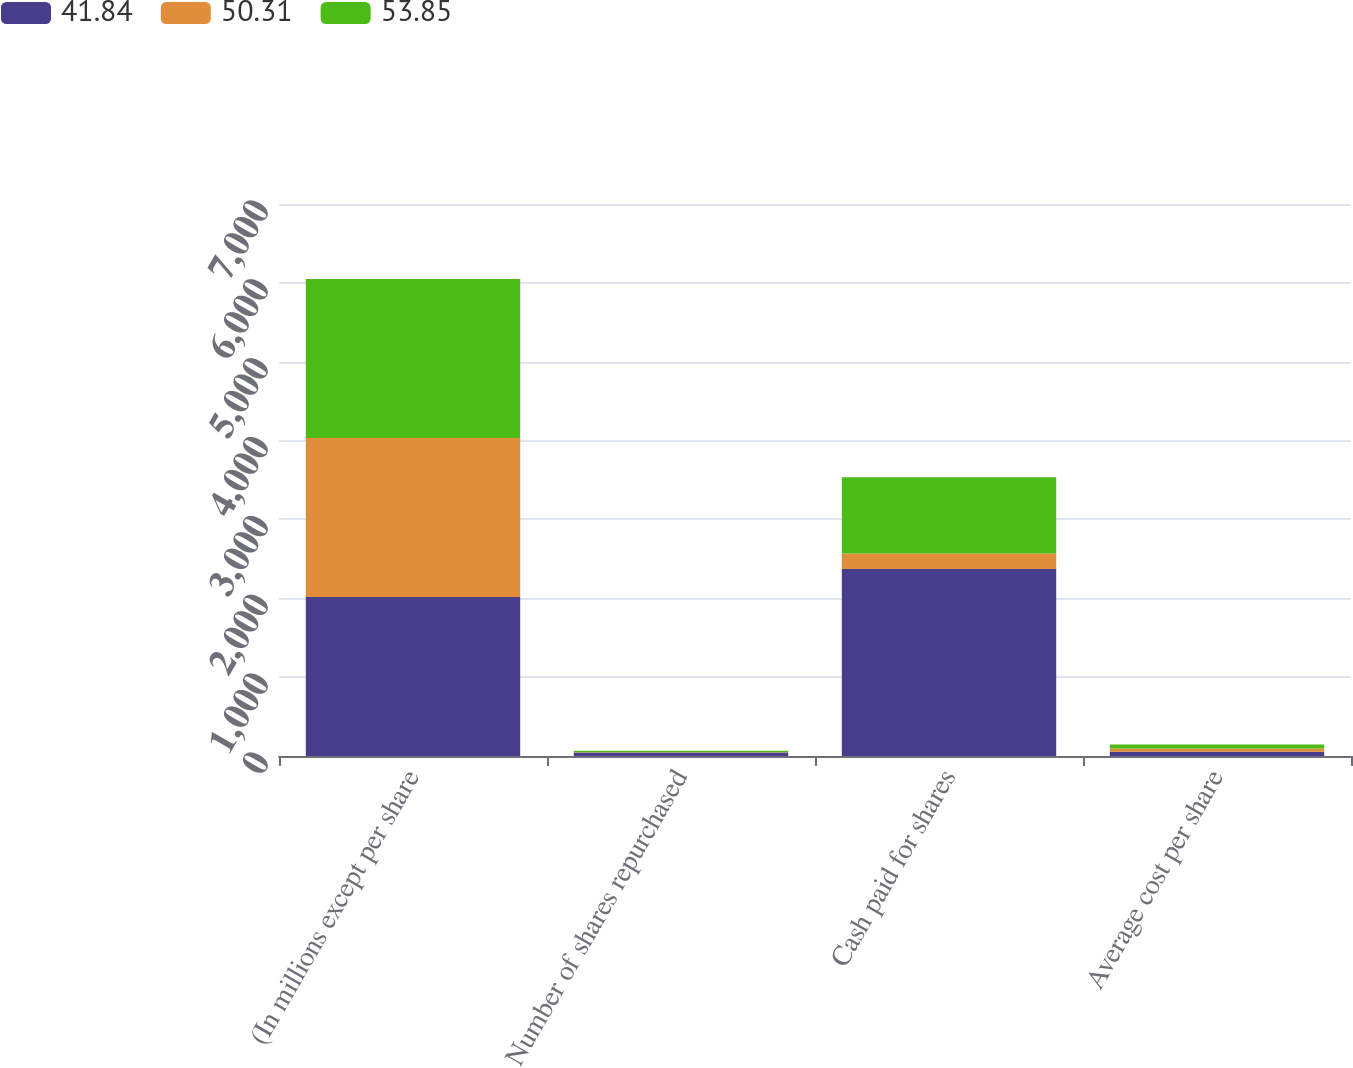<chart> <loc_0><loc_0><loc_500><loc_500><stacked_bar_chart><ecel><fcel>(In millions except per share<fcel>Number of shares repurchased<fcel>Cash paid for shares<fcel>Average cost per share<nl><fcel>41.84<fcel>2017<fcel>44<fcel>2372<fcel>53.85<nl><fcel>50.31<fcel>2016<fcel>4<fcel>197<fcel>41.84<nl><fcel>53.85<fcel>2015<fcel>19<fcel>965<fcel>50.31<nl></chart> 